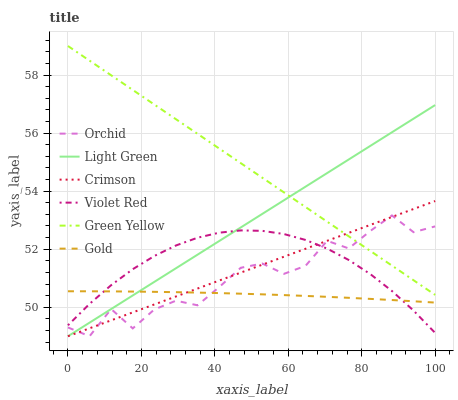Does Gold have the minimum area under the curve?
Answer yes or no. Yes. Does Green Yellow have the maximum area under the curve?
Answer yes or no. Yes. Does Light Green have the minimum area under the curve?
Answer yes or no. No. Does Light Green have the maximum area under the curve?
Answer yes or no. No. Is Light Green the smoothest?
Answer yes or no. Yes. Is Orchid the roughest?
Answer yes or no. Yes. Is Gold the smoothest?
Answer yes or no. No. Is Gold the roughest?
Answer yes or no. No. Does Light Green have the lowest value?
Answer yes or no. Yes. Does Gold have the lowest value?
Answer yes or no. No. Does Green Yellow have the highest value?
Answer yes or no. Yes. Does Light Green have the highest value?
Answer yes or no. No. Is Gold less than Green Yellow?
Answer yes or no. Yes. Is Green Yellow greater than Violet Red?
Answer yes or no. Yes. Does Light Green intersect Orchid?
Answer yes or no. Yes. Is Light Green less than Orchid?
Answer yes or no. No. Is Light Green greater than Orchid?
Answer yes or no. No. Does Gold intersect Green Yellow?
Answer yes or no. No. 